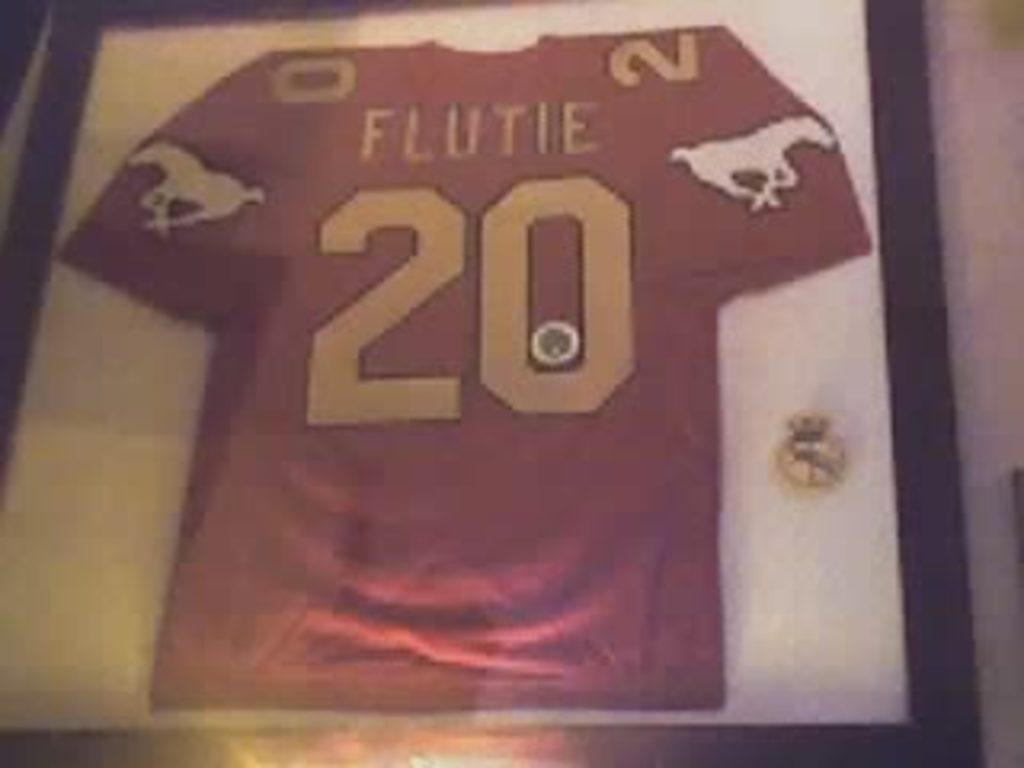<image>
Offer a succinct explanation of the picture presented. A red jersey with the number 20 with the name Flutie and a white horse on each sleeve sits on a white background surrounded by a dark wooden frame.. 